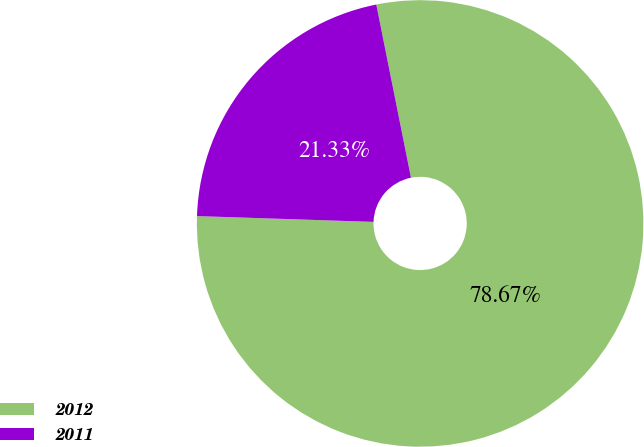<chart> <loc_0><loc_0><loc_500><loc_500><pie_chart><fcel>2012<fcel>2011<nl><fcel>78.67%<fcel>21.33%<nl></chart> 